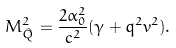Convert formula to latex. <formula><loc_0><loc_0><loc_500><loc_500>M _ { \hat { Q } } ^ { 2 } = \frac { { 2 } \alpha _ { 0 } ^ { 2 } } { c ^ { 2 } } ( \gamma + q ^ { 2 } v ^ { 2 } ) .</formula> 